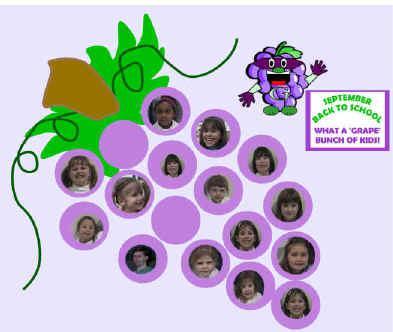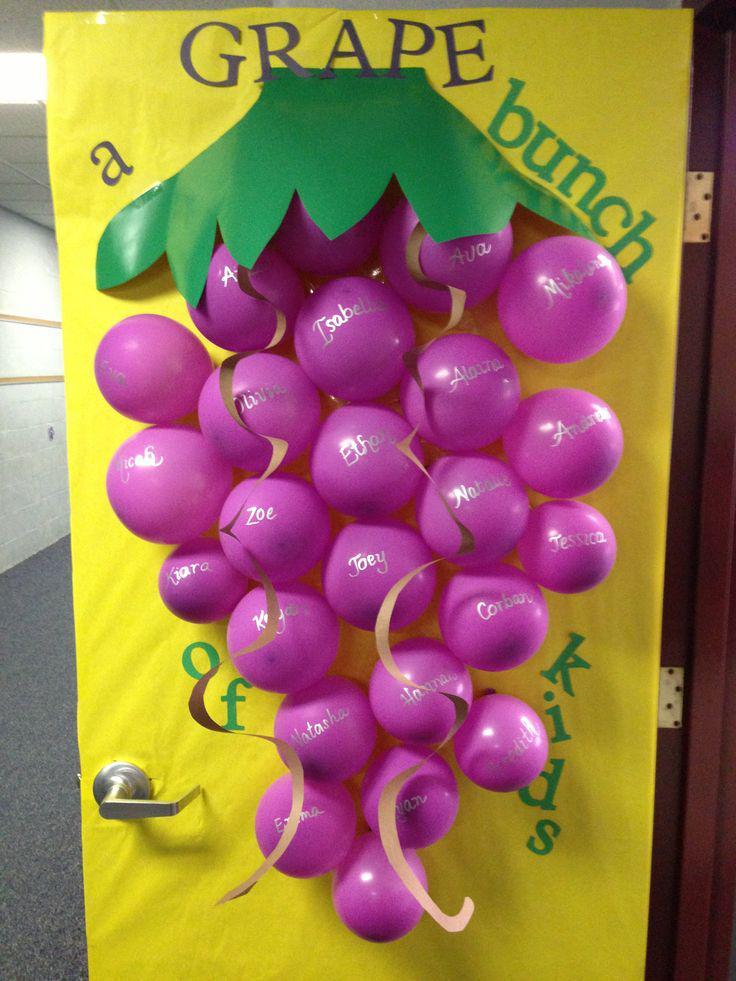The first image is the image on the left, the second image is the image on the right. Evaluate the accuracy of this statement regarding the images: "The right image shows purple balloons used to represent grapes in a cluster, and the left image shows childrens' faces in the center of purple circles.". Is it true? Answer yes or no. Yes. The first image is the image on the left, the second image is the image on the right. For the images shown, is this caption "Balloons hang from a poster in the image on the right." true? Answer yes or no. Yes. 